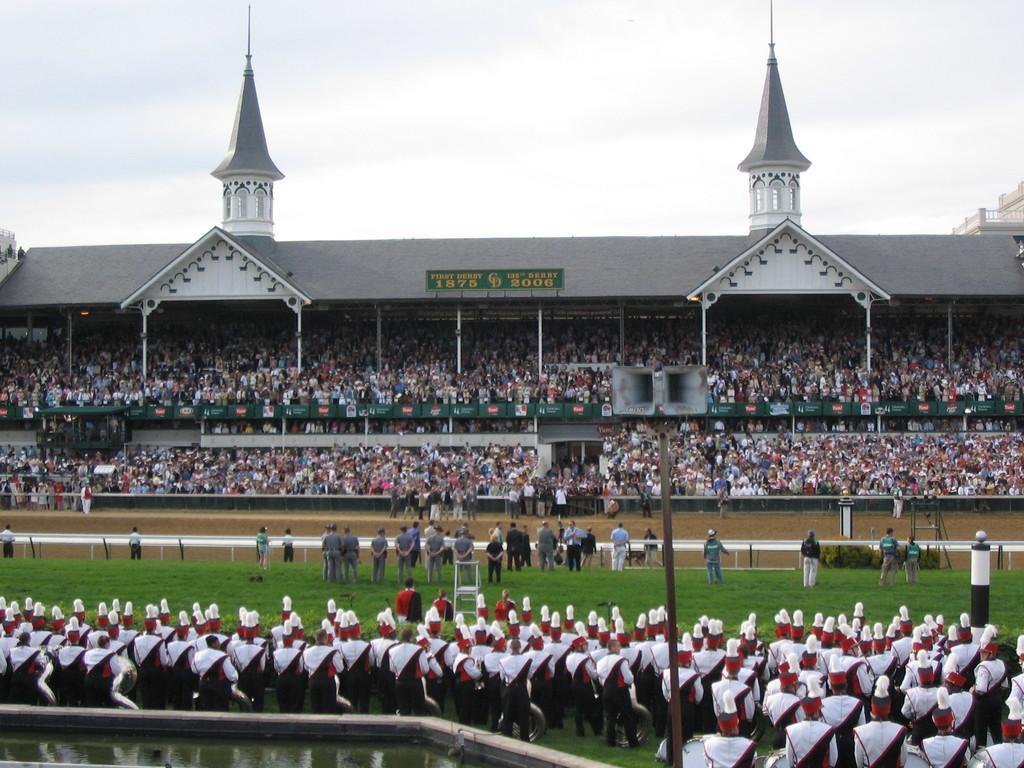How many people are in the image? There is a group of people in the image. What are the people doing in the image? Some people are standing on the ground, some are standing on a pole, and some are standing on a fence. What can be seen in the background of the image? The sky is visible in the background of the image. What type of floor can be seen in the image? There is no floor visible in the image; the people are standing on the ground, a pole, and a fence. 